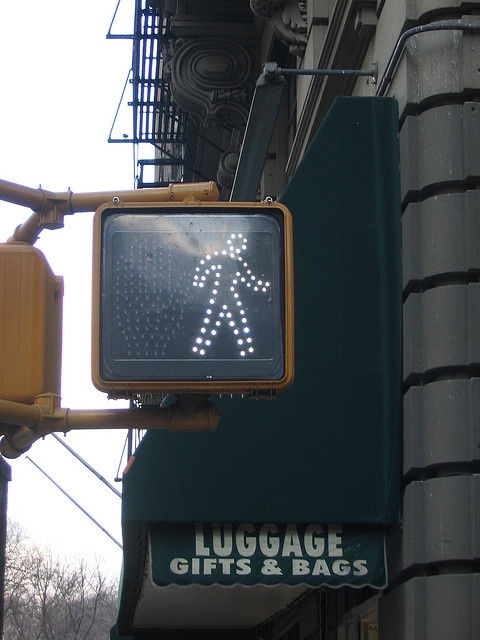Describe the objects in this image and their specific colors. I can see a traffic light in white, gray, darkblue, and darkgray tones in this image. 